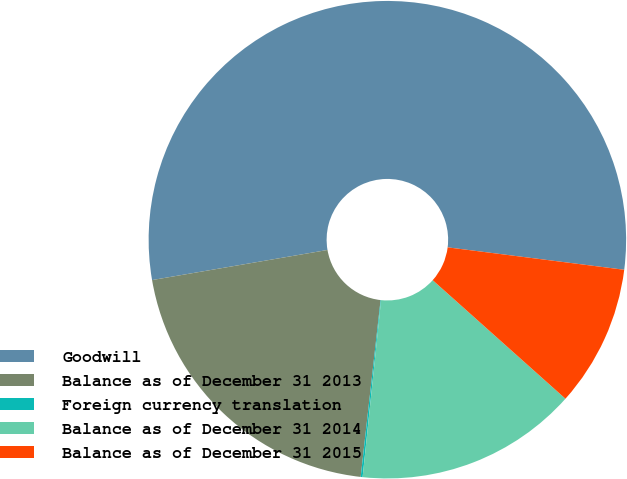Convert chart to OTSL. <chart><loc_0><loc_0><loc_500><loc_500><pie_chart><fcel>Goodwill<fcel>Balance as of December 31 2013<fcel>Foreign currency translation<fcel>Balance as of December 31 2014<fcel>Balance as of December 31 2015<nl><fcel>54.71%<fcel>20.51%<fcel>0.13%<fcel>15.05%<fcel>9.59%<nl></chart> 